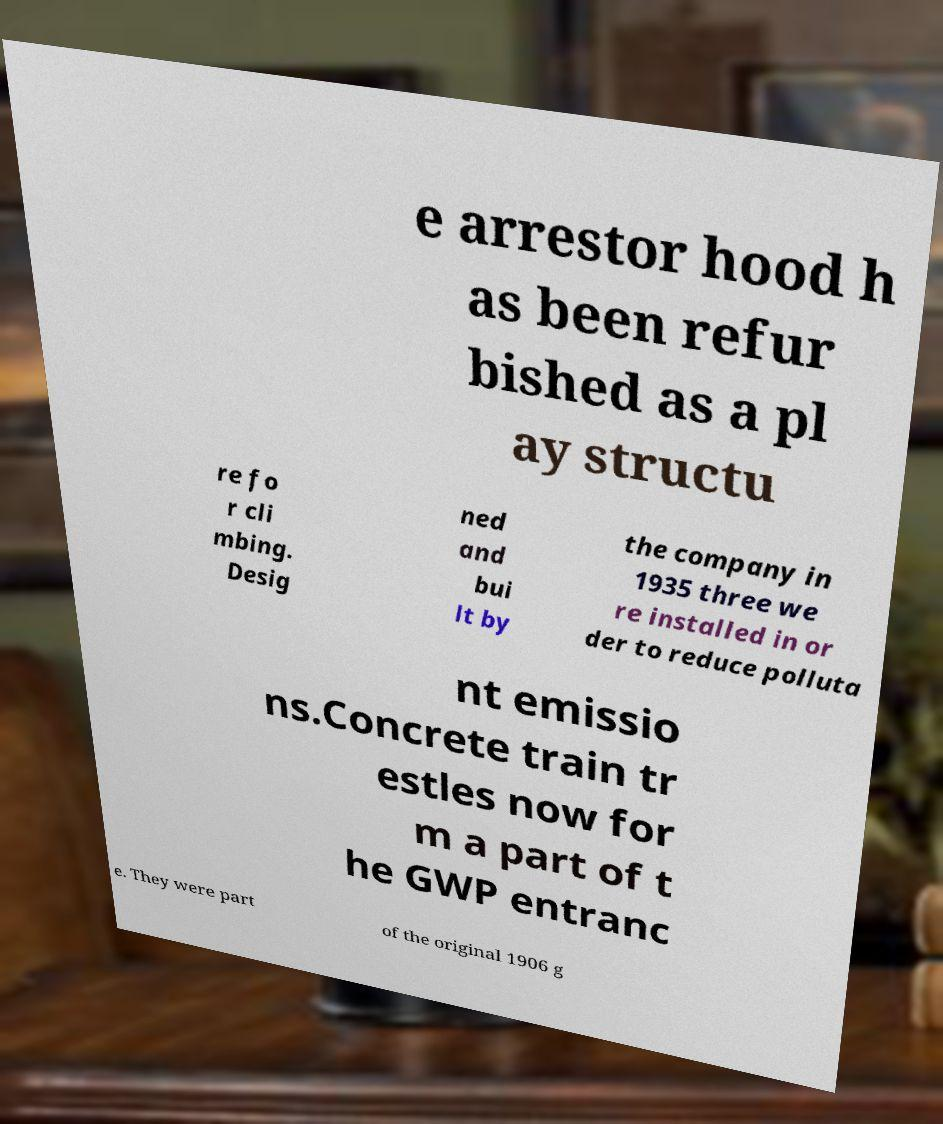For documentation purposes, I need the text within this image transcribed. Could you provide that? e arrestor hood h as been refur bished as a pl ay structu re fo r cli mbing. Desig ned and bui lt by the company in 1935 three we re installed in or der to reduce polluta nt emissio ns.Concrete train tr estles now for m a part of t he GWP entranc e. They were part of the original 1906 g 